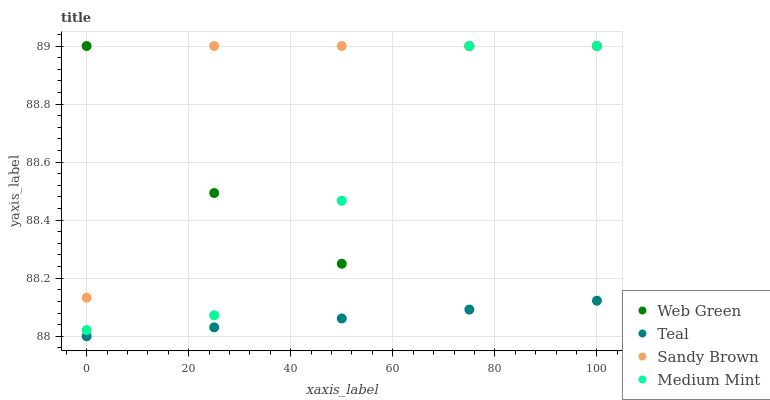Does Teal have the minimum area under the curve?
Answer yes or no. Yes. Does Sandy Brown have the maximum area under the curve?
Answer yes or no. Yes. Does Sandy Brown have the minimum area under the curve?
Answer yes or no. No. Does Teal have the maximum area under the curve?
Answer yes or no. No. Is Teal the smoothest?
Answer yes or no. Yes. Is Web Green the roughest?
Answer yes or no. Yes. Is Sandy Brown the smoothest?
Answer yes or no. No. Is Sandy Brown the roughest?
Answer yes or no. No. Does Teal have the lowest value?
Answer yes or no. Yes. Does Sandy Brown have the lowest value?
Answer yes or no. No. Does Web Green have the highest value?
Answer yes or no. Yes. Does Teal have the highest value?
Answer yes or no. No. Is Teal less than Sandy Brown?
Answer yes or no. Yes. Is Web Green greater than Teal?
Answer yes or no. Yes. Does Medium Mint intersect Web Green?
Answer yes or no. Yes. Is Medium Mint less than Web Green?
Answer yes or no. No. Is Medium Mint greater than Web Green?
Answer yes or no. No. Does Teal intersect Sandy Brown?
Answer yes or no. No. 